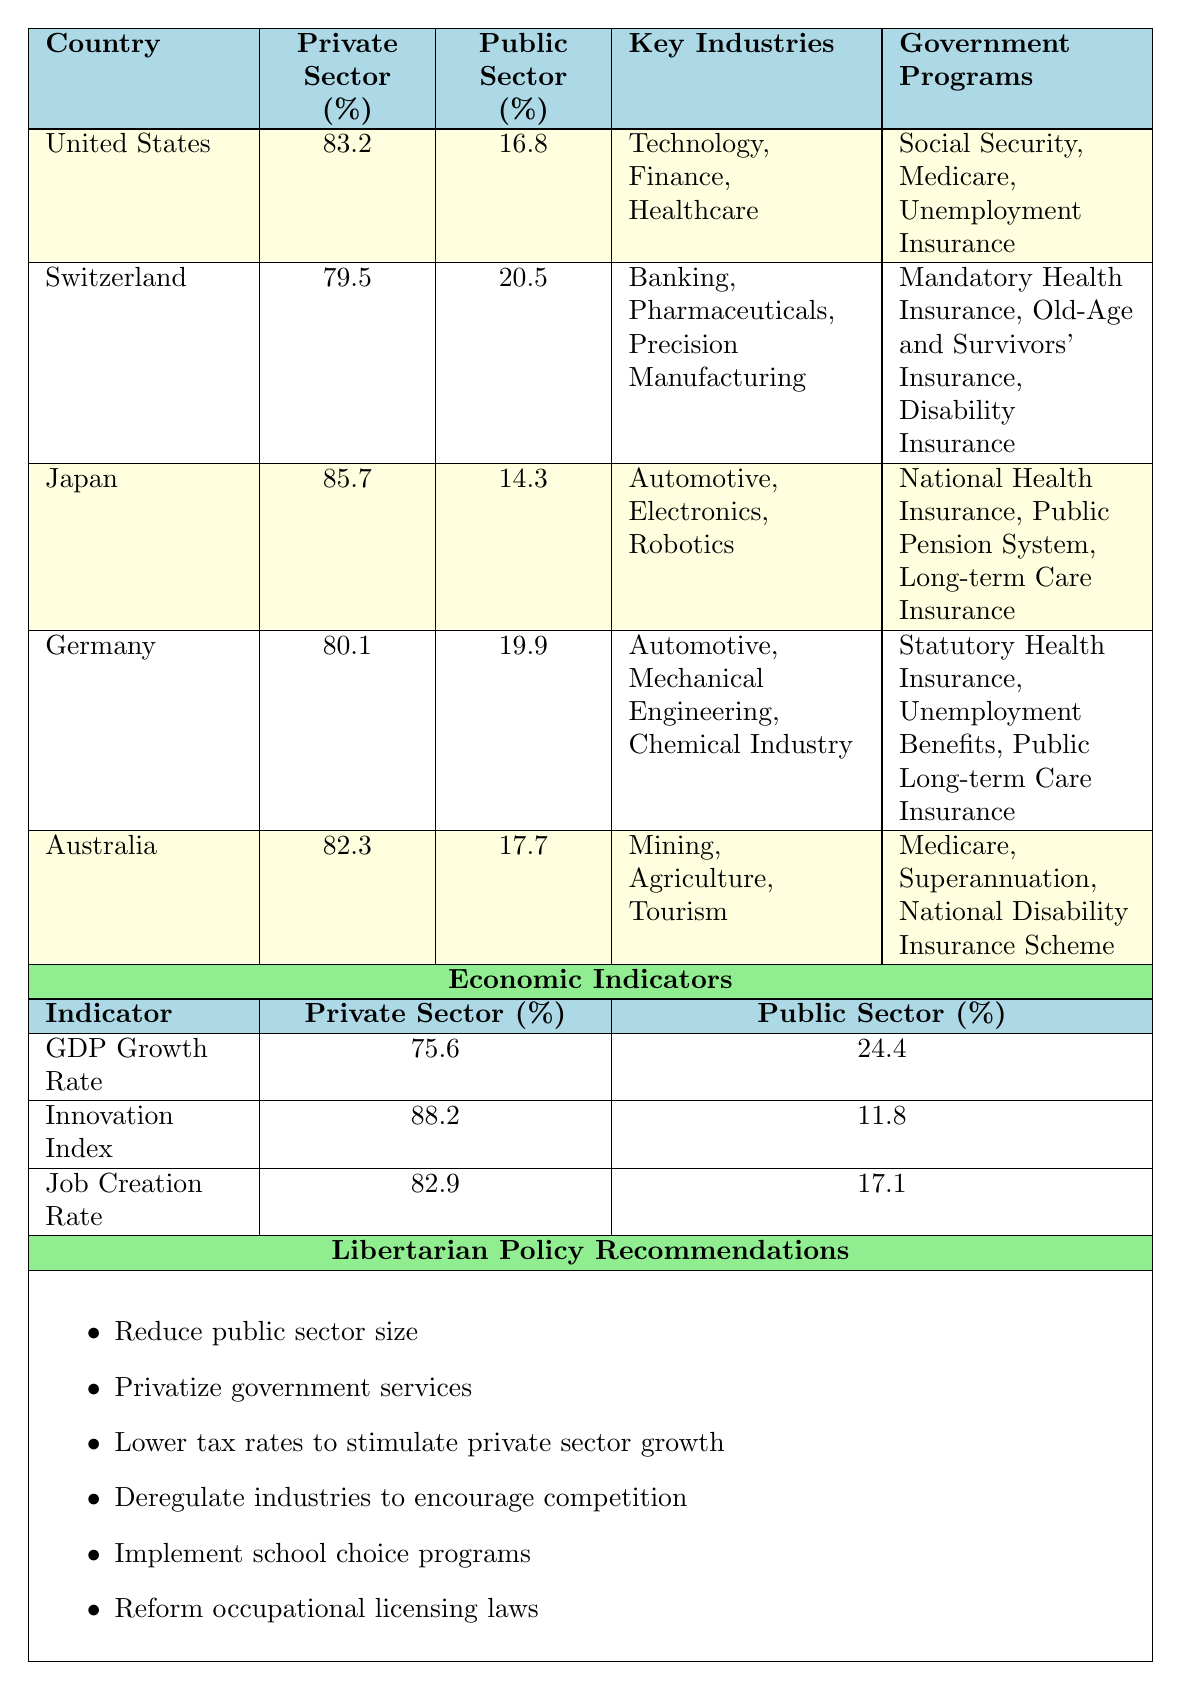What is the private sector employment rate in Germany? According to the table, Germany's private sector employment rate is specifically listed as 80.1%.
Answer: 80.1% Which country has the highest public sector employment rate? In the table, Switzerland has the highest public sector employment rate at 20.5%.
Answer: Switzerland What are the key industries in the United States? The table lists the key industries in the United States as Technology, Finance, and Healthcare.
Answer: Technology, Finance, Healthcare What is the difference between the private sector employment rates of Japan and Australia? Japan's private sector employment rate is 85.7% and Australia’s is 82.3%. The difference is 85.7% - 82.3% = 3.4%.
Answer: 3.4% Is the public sector employment rate in Japan less than 15%? The table indicates that Japan's public sector employment rate is 14.3%, which is indeed less than 15%.
Answer: Yes What is the average private sector employment rate of all the countries listed? The table shows private sector employment rates for five countries. Adding them gives 83.2 + 79.5 + 85.7 + 80.1 + 82.3 = 410.8. Dividing by 5 yields an average of 82.16%.
Answer: 82.16% Which countries have key industries in banking? Switzerland is the only country in the table with key industries listed as Banking.
Answer: Switzerland What is the percentage contribution of the public sector to the GDP growth rate? From the economic indicators section in the table, the public sector contribution to GDP growth rate is 24.4%.
Answer: 24.4% If the private sector contribution to job creation rate is 82.9%, what is the public sector's contribution? The table shows that the public sector contribution to the job creation rate is 17.1%, which is the complement to the private sector contribution.
Answer: 17.1% Which libertarian policy recommends lowering tax rates? The table states one of the libertarian policy recommendations is to lower tax rates to stimulate private sector growth.
Answer: Lower tax rates to stimulate private sector growth 